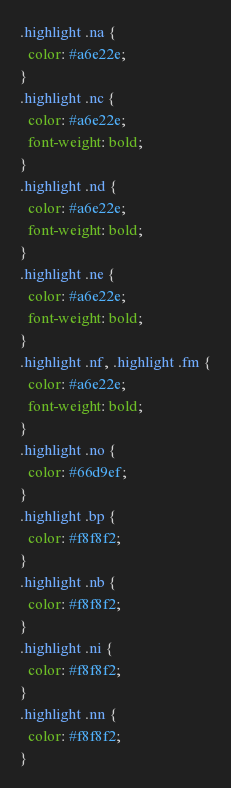<code> <loc_0><loc_0><loc_500><loc_500><_CSS_>.highlight .na {
  color: #a6e22e;
}
.highlight .nc {
  color: #a6e22e;
  font-weight: bold;
}
.highlight .nd {
  color: #a6e22e;
  font-weight: bold;
}
.highlight .ne {
  color: #a6e22e;
  font-weight: bold;
}
.highlight .nf, .highlight .fm {
  color: #a6e22e;
  font-weight: bold;
}
.highlight .no {
  color: #66d9ef;
}
.highlight .bp {
  color: #f8f8f2;
}
.highlight .nb {
  color: #f8f8f2;
}
.highlight .ni {
  color: #f8f8f2;
}
.highlight .nn {
  color: #f8f8f2;
}</code> 